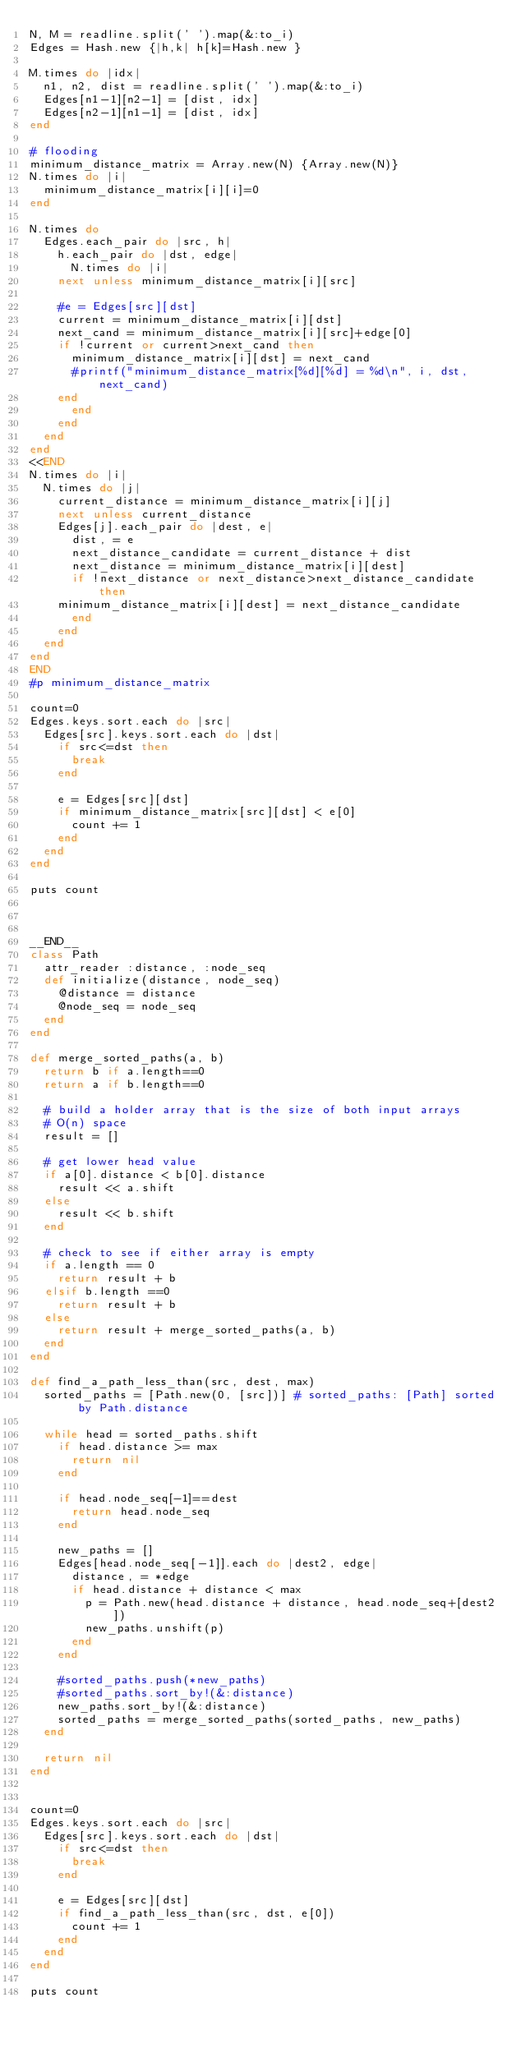Convert code to text. <code><loc_0><loc_0><loc_500><loc_500><_Ruby_>N, M = readline.split(' ').map(&:to_i)
Edges = Hash.new {|h,k| h[k]=Hash.new }

M.times do |idx|
  n1, n2, dist = readline.split(' ').map(&:to_i)
  Edges[n1-1][n2-1] = [dist, idx]
  Edges[n2-1][n1-1] = [dist, idx]
end

# flooding
minimum_distance_matrix = Array.new(N) {Array.new(N)}
N.times do |i|
  minimum_distance_matrix[i][i]=0
end

N.times do
  Edges.each_pair do |src, h|
    h.each_pair do |dst, edge|
      N.times do |i|
	next unless minimum_distance_matrix[i][src]

	#e = Edges[src][dst]
	current = minimum_distance_matrix[i][dst]
	next_cand = minimum_distance_matrix[i][src]+edge[0]
	if !current or current>next_cand then
	  minimum_distance_matrix[i][dst] = next_cand
	  #printf("minimum_distance_matrix[%d][%d] = %d\n", i, dst, next_cand)
	end
      end
    end
  end
end
<<END
N.times do |i|
  N.times do |j|
    current_distance = minimum_distance_matrix[i][j]
    next unless current_distance
    Edges[j].each_pair do |dest, e|
      dist, = e
      next_distance_candidate = current_distance + dist
      next_distance = minimum_distance_matrix[i][dest]
      if !next_distance or next_distance>next_distance_candidate then
	minimum_distance_matrix[i][dest] = next_distance_candidate
      end
    end 
  end
end
END
#p minimum_distance_matrix

count=0
Edges.keys.sort.each do |src|
  Edges[src].keys.sort.each do |dst|
    if src<=dst then
      break
    end

    e = Edges[src][dst]
    if minimum_distance_matrix[src][dst] < e[0]
      count += 1
    end
  end
end

puts count



__END__
class Path
  attr_reader :distance, :node_seq
  def initialize(distance, node_seq)
    @distance = distance
    @node_seq = node_seq
  end
end

def merge_sorted_paths(a, b)
  return b if a.length==0
  return a if b.length==0

  # build a holder array that is the size of both input arrays
  # O(n) space
  result = []

  # get lower head value
  if a[0].distance < b[0].distance
    result << a.shift
  else
    result << b.shift
  end

  # check to see if either array is empty
  if a.length == 0
    return result + b
  elsif b.length ==0
    return result + b
  else
    return result + merge_sorted_paths(a, b)
  end
end

def find_a_path_less_than(src, dest, max)
  sorted_paths = [Path.new(0, [src])] # sorted_paths: [Path] sorted by Path.distance

  while head = sorted_paths.shift
    if head.distance >= max
      return nil
    end

    if head.node_seq[-1]==dest
      return head.node_seq
    end

    new_paths = []
    Edges[head.node_seq[-1]].each do |dest2, edge|
      distance, = *edge
      if head.distance + distance < max
        p = Path.new(head.distance + distance, head.node_seq+[dest2])
        new_paths.unshift(p)
      end
    end

    #sorted_paths.push(*new_paths)
    #sorted_paths.sort_by!(&:distance)
    new_paths.sort_by!(&:distance)
    sorted_paths = merge_sorted_paths(sorted_paths, new_paths)
  end

  return nil
end


count=0
Edges.keys.sort.each do |src|
  Edges[src].keys.sort.each do |dst|
    if src<=dst then
      break
    end

    e = Edges[src][dst]
    if find_a_path_less_than(src, dst, e[0])
      count += 1
    end
  end
end

puts count


</code> 